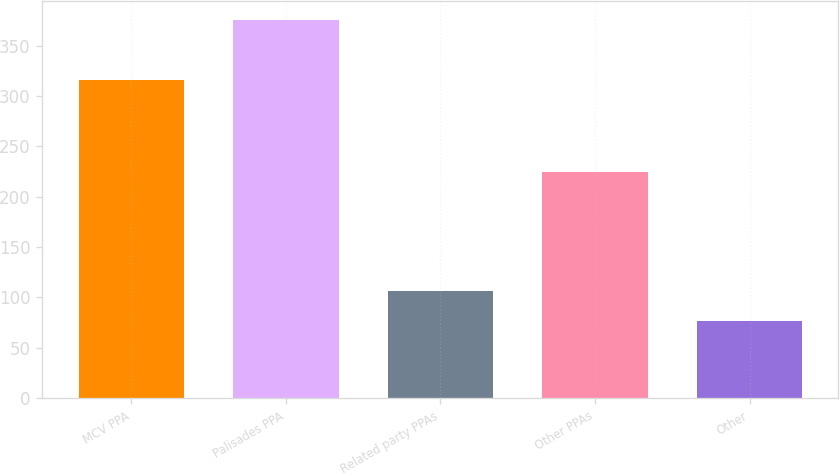<chart> <loc_0><loc_0><loc_500><loc_500><bar_chart><fcel>MCV PPA<fcel>Palisades PPA<fcel>Related party PPAs<fcel>Other PPAs<fcel>Other<nl><fcel>316<fcel>375<fcel>105.9<fcel>224<fcel>76<nl></chart> 